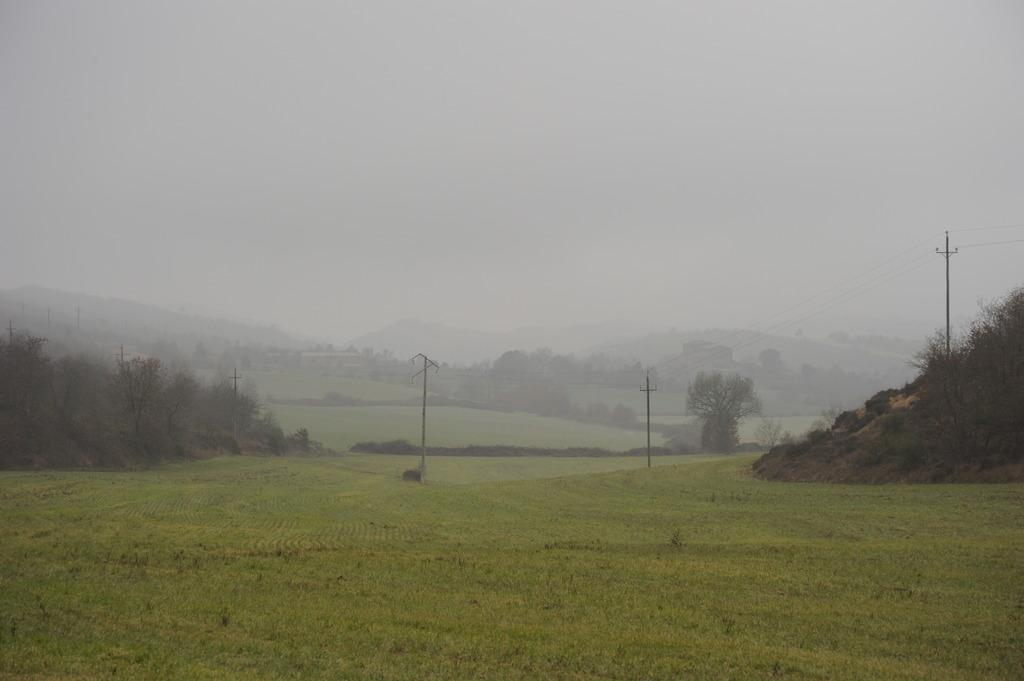What can be seen at the bottom of the image? The ground is visible in the image. What structures are present in the image? There are current poles in the image. What type of vegetation is present in the image? There are many trees to the side in the image. What is visible in the distance in the image? There is a mountain in the background of the image. What is the color of the sky in the image? The sky is white in the image. What type of silver object can be seen on the nose of the person in the image? There is no person or silver object present in the image. What holiday is being celebrated in the image? There is no indication of a holiday being celebrated in the image. 